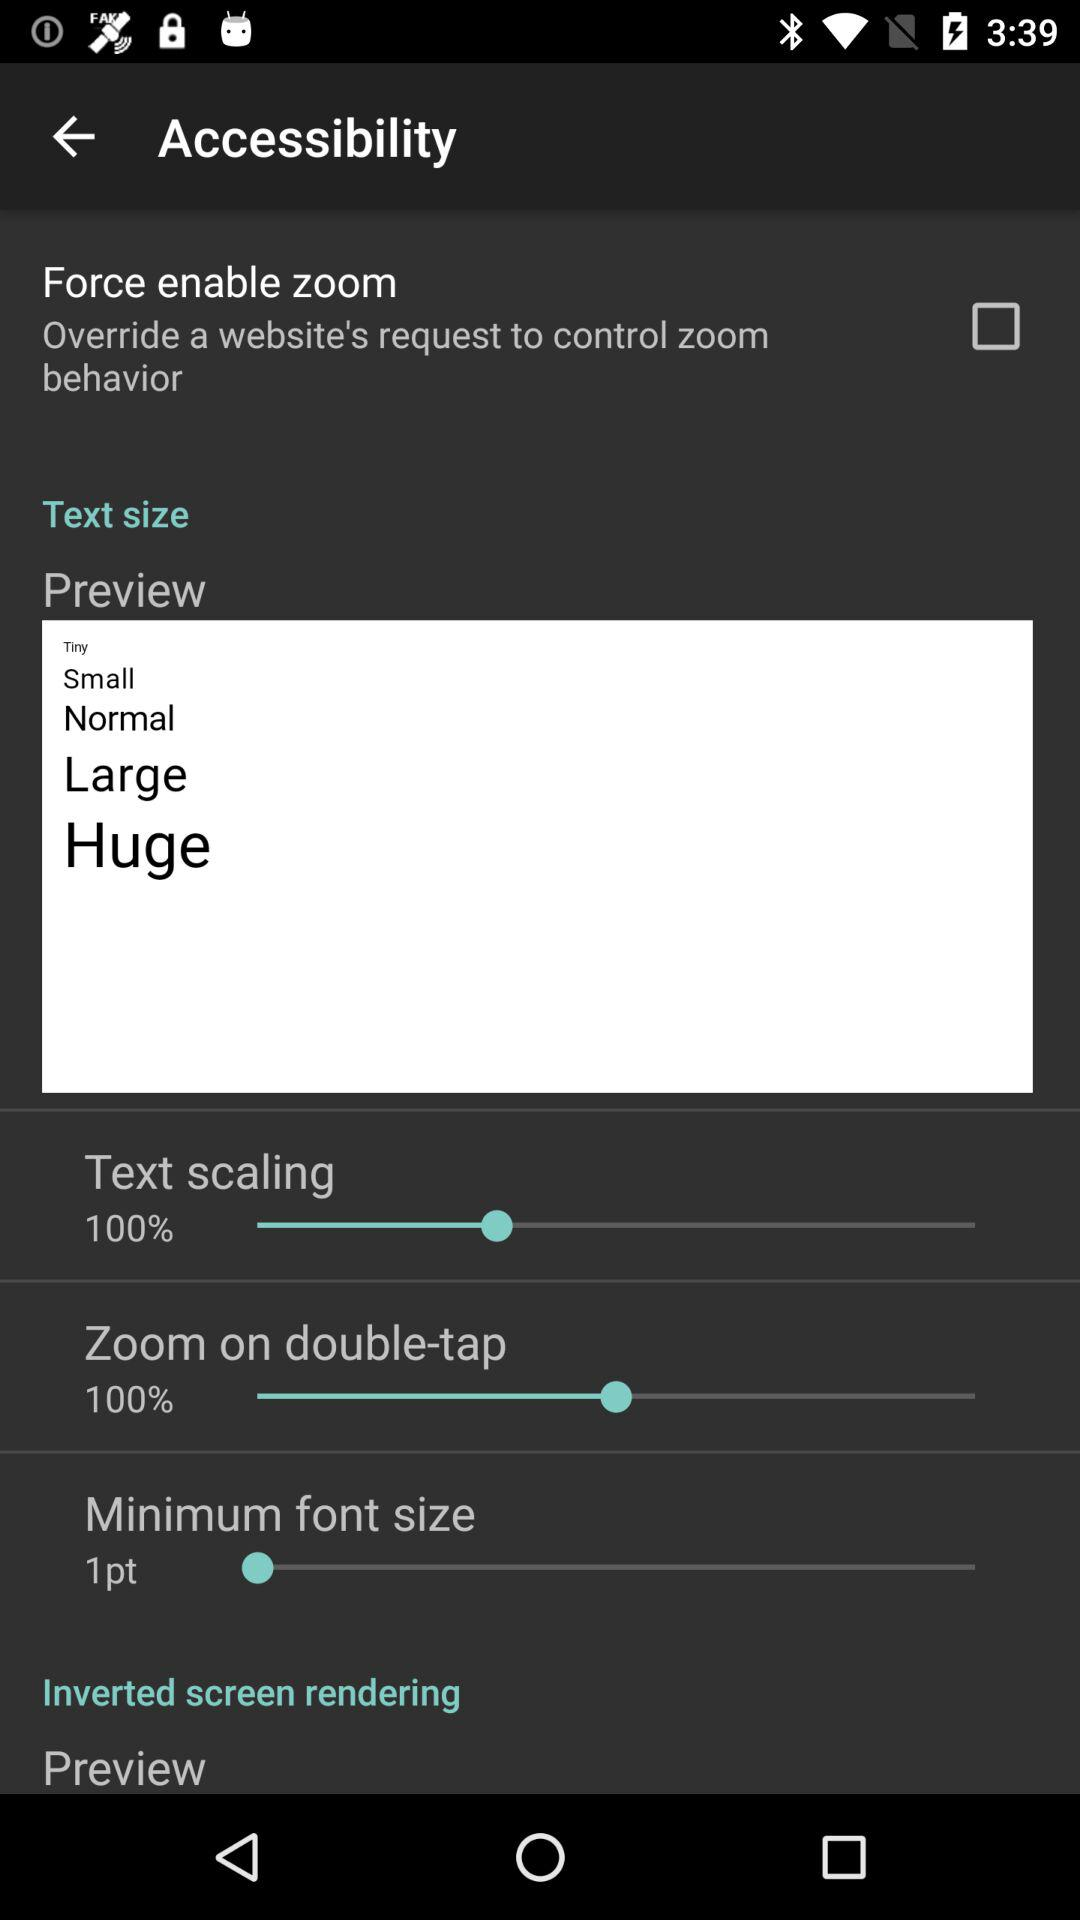What is the minimum font size? The minimum font size is 1 pt. 